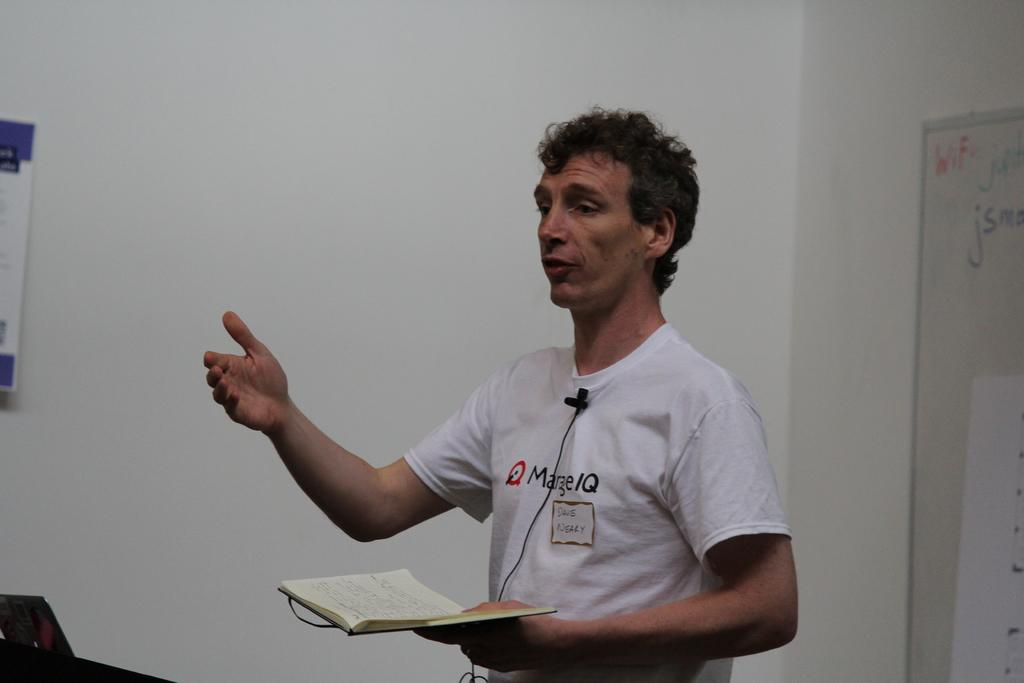<image>
Relay a brief, clear account of the picture shown. A man named Dale Nealy is giving a talk. 